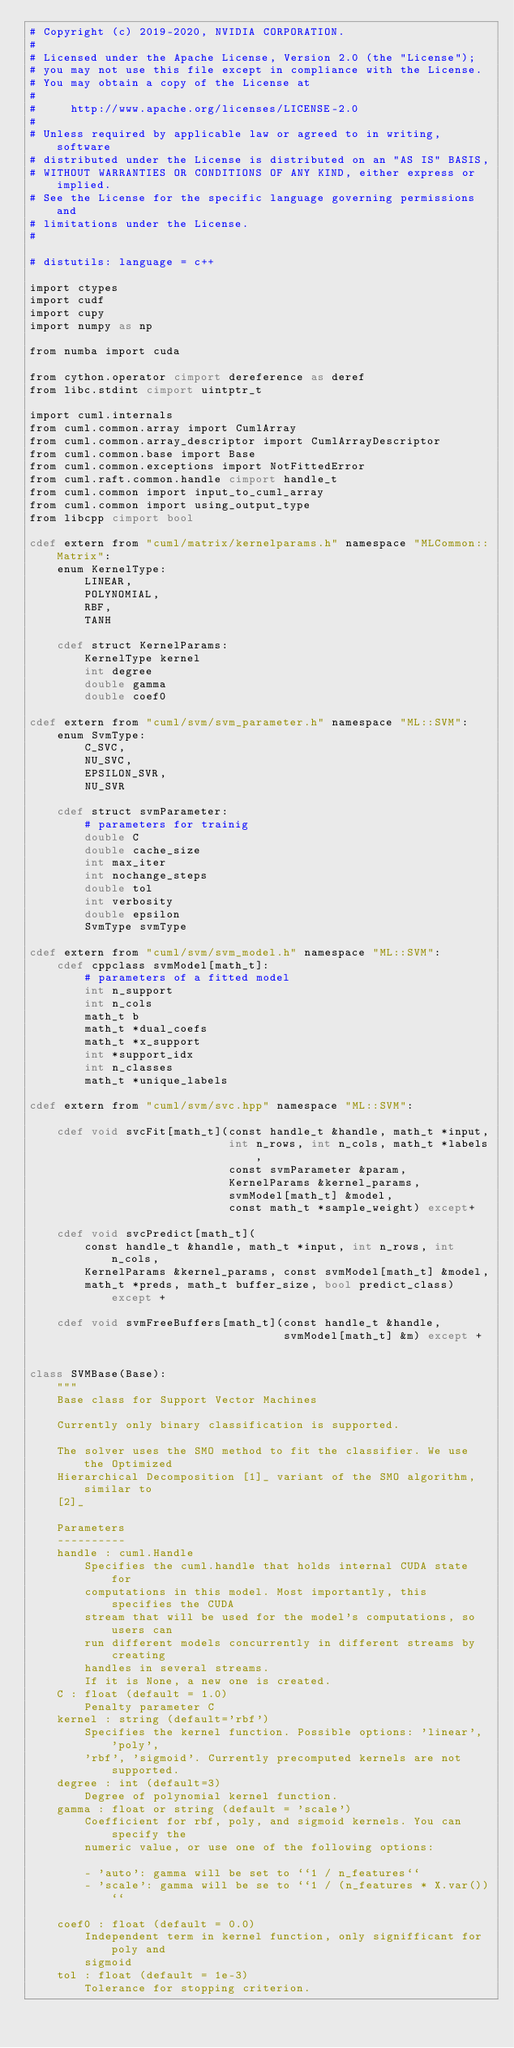<code> <loc_0><loc_0><loc_500><loc_500><_Cython_># Copyright (c) 2019-2020, NVIDIA CORPORATION.
#
# Licensed under the Apache License, Version 2.0 (the "License");
# you may not use this file except in compliance with the License.
# You may obtain a copy of the License at
#
#     http://www.apache.org/licenses/LICENSE-2.0
#
# Unless required by applicable law or agreed to in writing, software
# distributed under the License is distributed on an "AS IS" BASIS,
# WITHOUT WARRANTIES OR CONDITIONS OF ANY KIND, either express or implied.
# See the License for the specific language governing permissions and
# limitations under the License.
#

# distutils: language = c++

import ctypes
import cudf
import cupy
import numpy as np

from numba import cuda

from cython.operator cimport dereference as deref
from libc.stdint cimport uintptr_t

import cuml.internals
from cuml.common.array import CumlArray
from cuml.common.array_descriptor import CumlArrayDescriptor
from cuml.common.base import Base
from cuml.common.exceptions import NotFittedError
from cuml.raft.common.handle cimport handle_t
from cuml.common import input_to_cuml_array
from cuml.common import using_output_type
from libcpp cimport bool

cdef extern from "cuml/matrix/kernelparams.h" namespace "MLCommon::Matrix":
    enum KernelType:
        LINEAR,
        POLYNOMIAL,
        RBF,
        TANH

    cdef struct KernelParams:
        KernelType kernel
        int degree
        double gamma
        double coef0

cdef extern from "cuml/svm/svm_parameter.h" namespace "ML::SVM":
    enum SvmType:
        C_SVC,
        NU_SVC,
        EPSILON_SVR,
        NU_SVR

    cdef struct svmParameter:
        # parameters for trainig
        double C
        double cache_size
        int max_iter
        int nochange_steps
        double tol
        int verbosity
        double epsilon
        SvmType svmType

cdef extern from "cuml/svm/svm_model.h" namespace "ML::SVM":
    cdef cppclass svmModel[math_t]:
        # parameters of a fitted model
        int n_support
        int n_cols
        math_t b
        math_t *dual_coefs
        math_t *x_support
        int *support_idx
        int n_classes
        math_t *unique_labels

cdef extern from "cuml/svm/svc.hpp" namespace "ML::SVM":

    cdef void svcFit[math_t](const handle_t &handle, math_t *input,
                             int n_rows, int n_cols, math_t *labels,
                             const svmParameter &param,
                             KernelParams &kernel_params,
                             svmModel[math_t] &model,
                             const math_t *sample_weight) except+

    cdef void svcPredict[math_t](
        const handle_t &handle, math_t *input, int n_rows, int n_cols,
        KernelParams &kernel_params, const svmModel[math_t] &model,
        math_t *preds, math_t buffer_size, bool predict_class) except +

    cdef void svmFreeBuffers[math_t](const handle_t &handle,
                                     svmModel[math_t] &m) except +


class SVMBase(Base):
    """
    Base class for Support Vector Machines

    Currently only binary classification is supported.

    The solver uses the SMO method to fit the classifier. We use the Optimized
    Hierarchical Decomposition [1]_ variant of the SMO algorithm, similar to
    [2]_

    Parameters
    ----------
    handle : cuml.Handle
        Specifies the cuml.handle that holds internal CUDA state for
        computations in this model. Most importantly, this specifies the CUDA
        stream that will be used for the model's computations, so users can
        run different models concurrently in different streams by creating
        handles in several streams.
        If it is None, a new one is created.
    C : float (default = 1.0)
        Penalty parameter C
    kernel : string (default='rbf')
        Specifies the kernel function. Possible options: 'linear', 'poly',
        'rbf', 'sigmoid'. Currently precomputed kernels are not supported.
    degree : int (default=3)
        Degree of polynomial kernel function.
    gamma : float or string (default = 'scale')
        Coefficient for rbf, poly, and sigmoid kernels. You can specify the
        numeric value, or use one of the following options:

        - 'auto': gamma will be set to ``1 / n_features``
        - 'scale': gamma will be se to ``1 / (n_features * X.var())``

    coef0 : float (default = 0.0)
        Independent term in kernel function, only signifficant for poly and
        sigmoid
    tol : float (default = 1e-3)
        Tolerance for stopping criterion.</code> 